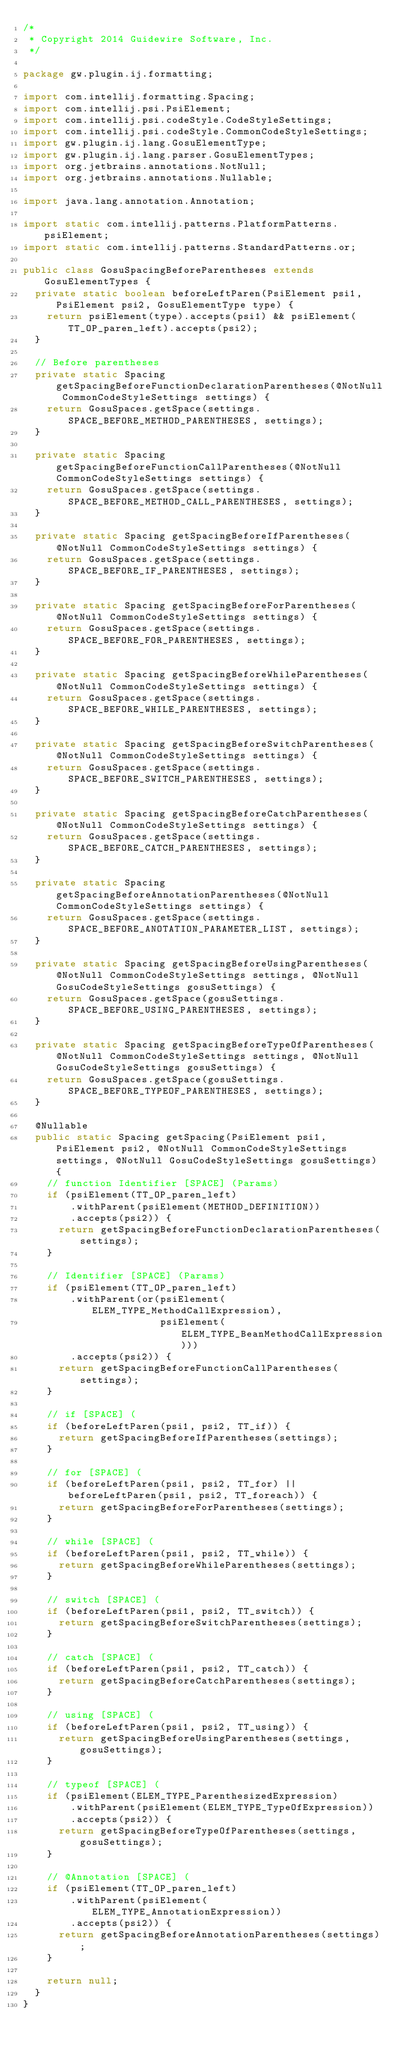Convert code to text. <code><loc_0><loc_0><loc_500><loc_500><_Java_>/*
 * Copyright 2014 Guidewire Software, Inc.
 */

package gw.plugin.ij.formatting;

import com.intellij.formatting.Spacing;
import com.intellij.psi.PsiElement;
import com.intellij.psi.codeStyle.CodeStyleSettings;
import com.intellij.psi.codeStyle.CommonCodeStyleSettings;
import gw.plugin.ij.lang.GosuElementType;
import gw.plugin.ij.lang.parser.GosuElementTypes;
import org.jetbrains.annotations.NotNull;
import org.jetbrains.annotations.Nullable;

import java.lang.annotation.Annotation;

import static com.intellij.patterns.PlatformPatterns.psiElement;
import static com.intellij.patterns.StandardPatterns.or;

public class GosuSpacingBeforeParentheses extends GosuElementTypes {
  private static boolean beforeLeftParen(PsiElement psi1, PsiElement psi2, GosuElementType type) {
    return psiElement(type).accepts(psi1) && psiElement(TT_OP_paren_left).accepts(psi2);
  }

  // Before parentheses
  private static Spacing getSpacingBeforeFunctionDeclarationParentheses(@NotNull CommonCodeStyleSettings settings) {
    return GosuSpaces.getSpace(settings.SPACE_BEFORE_METHOD_PARENTHESES, settings);
  }

  private static Spacing getSpacingBeforeFunctionCallParentheses(@NotNull CommonCodeStyleSettings settings) {
    return GosuSpaces.getSpace(settings.SPACE_BEFORE_METHOD_CALL_PARENTHESES, settings);
  }

  private static Spacing getSpacingBeforeIfParentheses(@NotNull CommonCodeStyleSettings settings) {
    return GosuSpaces.getSpace(settings.SPACE_BEFORE_IF_PARENTHESES, settings);
  }

  private static Spacing getSpacingBeforeForParentheses(@NotNull CommonCodeStyleSettings settings) {
    return GosuSpaces.getSpace(settings.SPACE_BEFORE_FOR_PARENTHESES, settings);
  }

  private static Spacing getSpacingBeforeWhileParentheses(@NotNull CommonCodeStyleSettings settings) {
    return GosuSpaces.getSpace(settings.SPACE_BEFORE_WHILE_PARENTHESES, settings);
  }

  private static Spacing getSpacingBeforeSwitchParentheses(@NotNull CommonCodeStyleSettings settings) {
    return GosuSpaces.getSpace(settings.SPACE_BEFORE_SWITCH_PARENTHESES, settings);
  }

  private static Spacing getSpacingBeforeCatchParentheses(@NotNull CommonCodeStyleSettings settings) {
    return GosuSpaces.getSpace(settings.SPACE_BEFORE_CATCH_PARENTHESES, settings);
  }

  private static Spacing getSpacingBeforeAnnotationParentheses(@NotNull CommonCodeStyleSettings settings) {
    return GosuSpaces.getSpace(settings.SPACE_BEFORE_ANOTATION_PARAMETER_LIST, settings);
  }

  private static Spacing getSpacingBeforeUsingParentheses(@NotNull CommonCodeStyleSettings settings, @NotNull GosuCodeStyleSettings gosuSettings) {
    return GosuSpaces.getSpace(gosuSettings.SPACE_BEFORE_USING_PARENTHESES, settings);
  }

  private static Spacing getSpacingBeforeTypeOfParentheses(@NotNull CommonCodeStyleSettings settings, @NotNull GosuCodeStyleSettings gosuSettings) {
    return GosuSpaces.getSpace(gosuSettings.SPACE_BEFORE_TYPEOF_PARENTHESES, settings);
  }

  @Nullable
  public static Spacing getSpacing(PsiElement psi1, PsiElement psi2, @NotNull CommonCodeStyleSettings settings, @NotNull GosuCodeStyleSettings gosuSettings) {
    // function Identifier [SPACE] (Params)
    if (psiElement(TT_OP_paren_left)
        .withParent(psiElement(METHOD_DEFINITION))
        .accepts(psi2)) {
      return getSpacingBeforeFunctionDeclarationParentheses(settings);
    }

    // Identifier [SPACE] (Params)
    if (psiElement(TT_OP_paren_left)
        .withParent(or(psiElement(ELEM_TYPE_MethodCallExpression),
                       psiElement(ELEM_TYPE_BeanMethodCallExpression)))
        .accepts(psi2)) {
      return getSpacingBeforeFunctionCallParentheses(settings);
    }

    // if [SPACE] (
    if (beforeLeftParen(psi1, psi2, TT_if)) {
      return getSpacingBeforeIfParentheses(settings);
    }

    // for [SPACE] (
    if (beforeLeftParen(psi1, psi2, TT_for) || beforeLeftParen(psi1, psi2, TT_foreach)) {
      return getSpacingBeforeForParentheses(settings);
    }

    // while [SPACE] (
    if (beforeLeftParen(psi1, psi2, TT_while)) {
      return getSpacingBeforeWhileParentheses(settings);
    }

    // switch [SPACE] (
    if (beforeLeftParen(psi1, psi2, TT_switch)) {
      return getSpacingBeforeSwitchParentheses(settings);
    }

    // catch [SPACE] (
    if (beforeLeftParen(psi1, psi2, TT_catch)) {
      return getSpacingBeforeCatchParentheses(settings);
    }

    // using [SPACE] (
    if (beforeLeftParen(psi1, psi2, TT_using)) {
      return getSpacingBeforeUsingParentheses(settings, gosuSettings);
    }

    // typeof [SPACE] (
    if (psiElement(ELEM_TYPE_ParenthesizedExpression)
        .withParent(psiElement(ELEM_TYPE_TypeOfExpression))
        .accepts(psi2)) {
      return getSpacingBeforeTypeOfParentheses(settings, gosuSettings);
    }

    // @Annotation [SPACE] (
    if (psiElement(TT_OP_paren_left)
        .withParent(psiElement(ELEM_TYPE_AnnotationExpression))
        .accepts(psi2)) {
      return getSpacingBeforeAnnotationParentheses(settings);
    }

    return null;
  }
}
</code> 